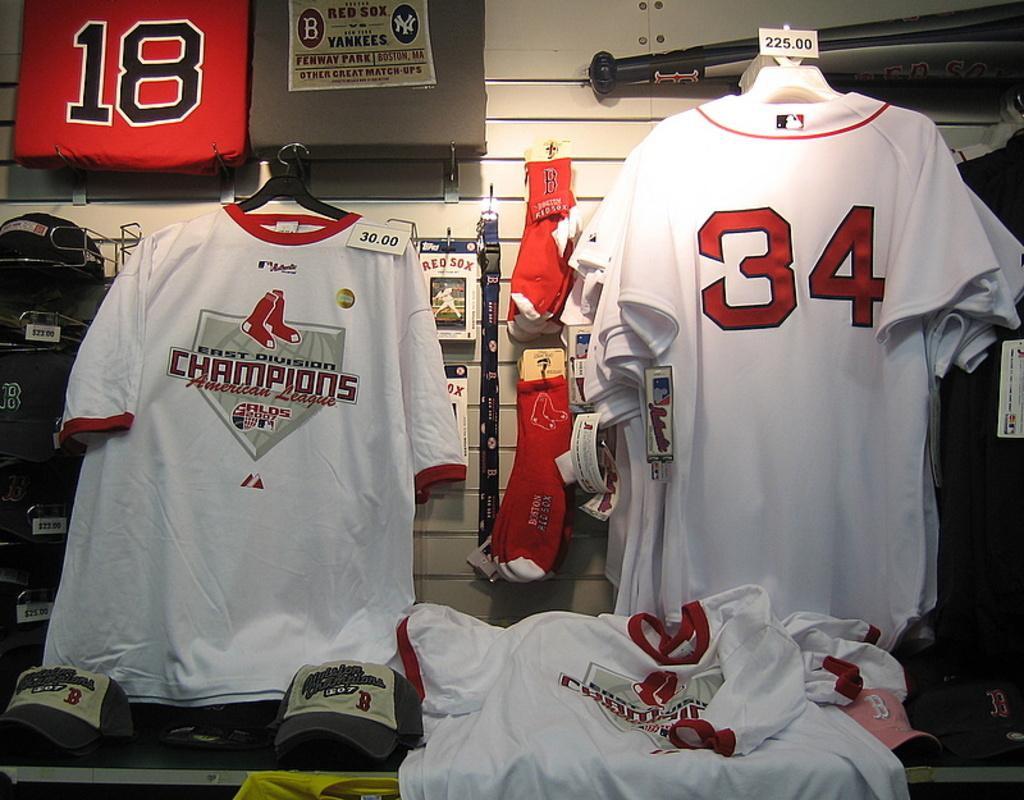Provide a one-sentence caption for the provided image. white shirts and jerseys with the number 34 on it. 